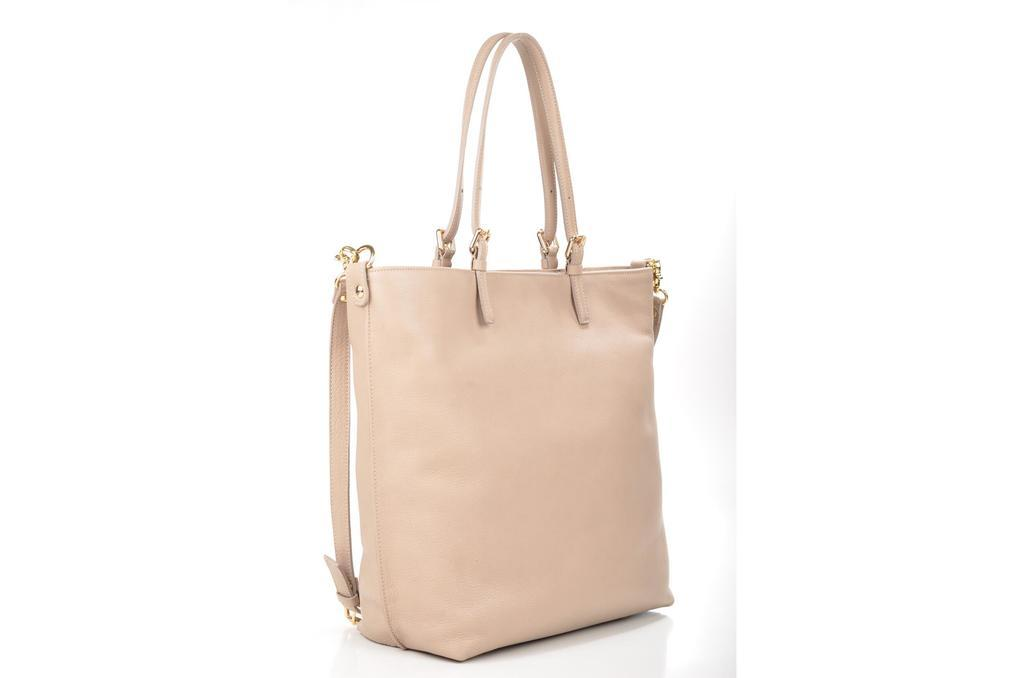What color is the bag that is visible in the image? The bag is cream-colored. What feature is attached to the bag in the image? The bag has a belt attached to it. What invention is being demonstrated in the image? There is no invention being demonstrated in the image; it simply shows a cream-colored bag with a belt attached to it. 